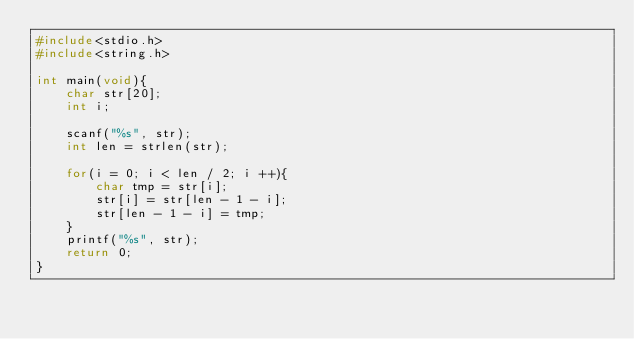<code> <loc_0><loc_0><loc_500><loc_500><_C_>#include<stdio.h>
#include<string.h>

int main(void){
	char str[20];
	int i;
	
	scanf("%s", str);
	int len = strlen(str);
	
	for(i = 0; i < len / 2; i ++){
		char tmp = str[i];
		str[i] = str[len - 1 - i];
		str[len - 1 - i] = tmp;
	}
	printf("%s", str);
	return 0;
}</code> 